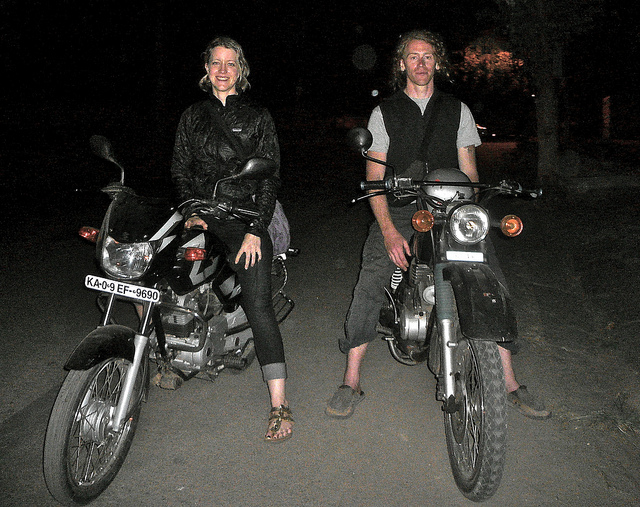Describe their attire and what that might imply about their ride. They are wearing casual, practical clothing with protective elements such as jackets and boots, implying they value safety while riding. It suggests their ride might have been a relaxed journey rather than a more formal or sport-oriented event. 